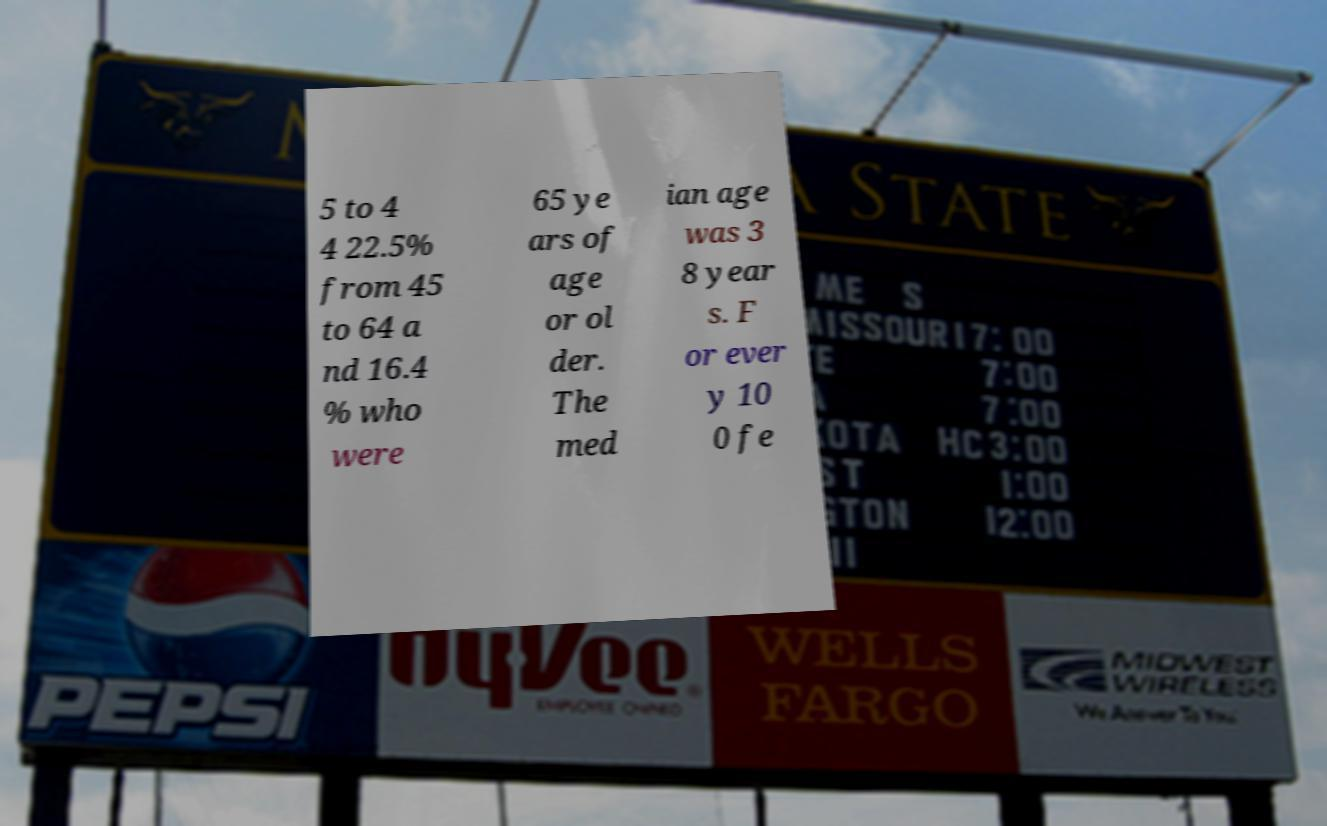What messages or text are displayed in this image? I need them in a readable, typed format. 5 to 4 4 22.5% from 45 to 64 a nd 16.4 % who were 65 ye ars of age or ol der. The med ian age was 3 8 year s. F or ever y 10 0 fe 